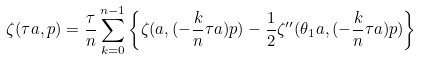Convert formula to latex. <formula><loc_0><loc_0><loc_500><loc_500>\zeta ( \tau a , p ) = \frac { \tau } { n } \sum _ { k = 0 } ^ { n - 1 } \left \{ \zeta ( a , ( - \frac { k } { n } \tau a ) p ) - \frac { 1 } { 2 } \zeta ^ { \prime \prime } ( \theta _ { 1 } a , ( - \frac { k } { n } \tau a ) p ) \right \}</formula> 